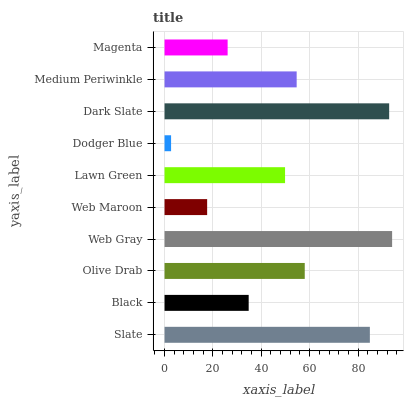Is Dodger Blue the minimum?
Answer yes or no. Yes. Is Web Gray the maximum?
Answer yes or no. Yes. Is Black the minimum?
Answer yes or no. No. Is Black the maximum?
Answer yes or no. No. Is Slate greater than Black?
Answer yes or no. Yes. Is Black less than Slate?
Answer yes or no. Yes. Is Black greater than Slate?
Answer yes or no. No. Is Slate less than Black?
Answer yes or no. No. Is Medium Periwinkle the high median?
Answer yes or no. Yes. Is Lawn Green the low median?
Answer yes or no. Yes. Is Web Gray the high median?
Answer yes or no. No. Is Magenta the low median?
Answer yes or no. No. 